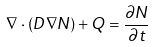<formula> <loc_0><loc_0><loc_500><loc_500>\nabla \cdot ( D \nabla N ) + Q = \frac { \partial N } { \partial t }</formula> 